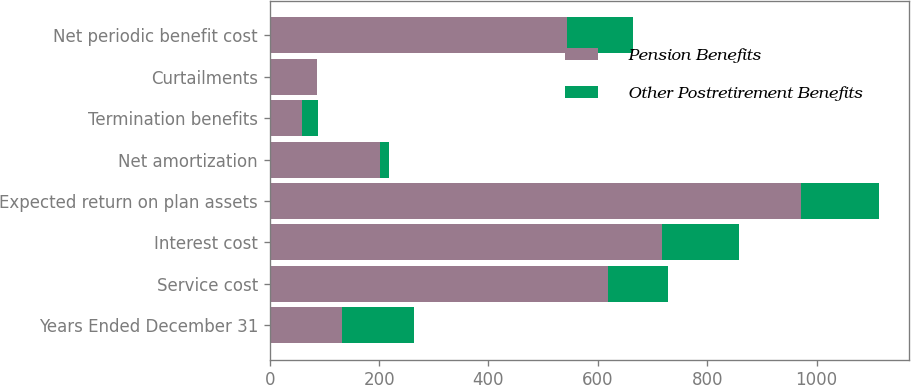Convert chart. <chart><loc_0><loc_0><loc_500><loc_500><stacked_bar_chart><ecel><fcel>Years Ended December 31<fcel>Service cost<fcel>Interest cost<fcel>Expected return on plan assets<fcel>Net amortization<fcel>Termination benefits<fcel>Curtailments<fcel>Net periodic benefit cost<nl><fcel>Pension Benefits<fcel>131.5<fcel>619<fcel>718<fcel>972<fcel>201<fcel>59<fcel>86<fcel>543<nl><fcel>Other Postretirement Benefits<fcel>131.5<fcel>110<fcel>141<fcel>142<fcel>17<fcel>29<fcel>1<fcel>122<nl></chart> 